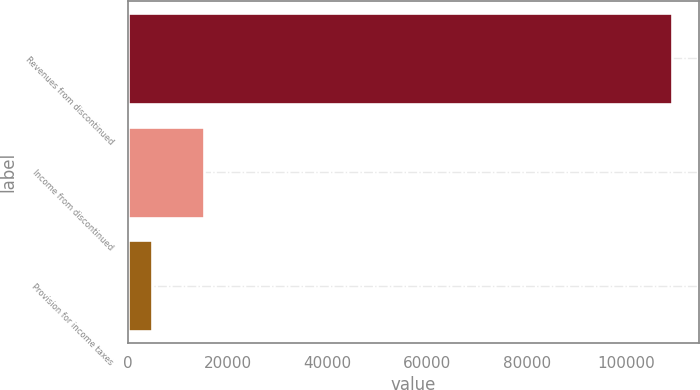<chart> <loc_0><loc_0><loc_500><loc_500><bar_chart><fcel>Revenues from discontinued<fcel>Income from discontinued<fcel>Provision for income taxes<nl><fcel>109151<fcel>15192.8<fcel>4753<nl></chart> 